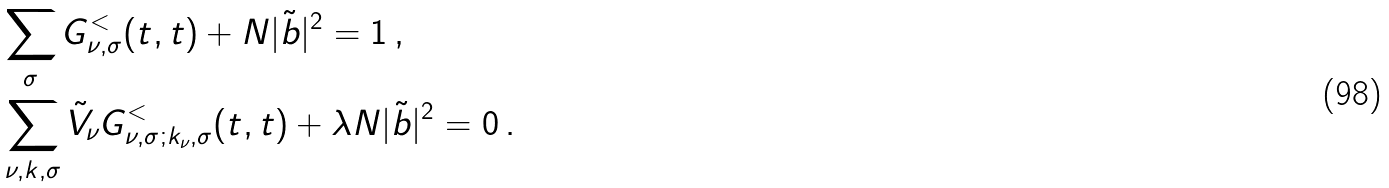Convert formula to latex. <formula><loc_0><loc_0><loc_500><loc_500>& \sum _ { \sigma } G ^ { < } _ { \nu , \sigma } ( t , t ) + N | \tilde { b } | ^ { 2 } = 1 \, , \\ & \sum _ { \nu , k , \sigma } \tilde { V } _ { \nu } G ^ { < } _ { \nu , \sigma ; k _ { \nu } , \sigma } ( t , t ) + \lambda N | \tilde { b } | ^ { 2 } = 0 \, .</formula> 